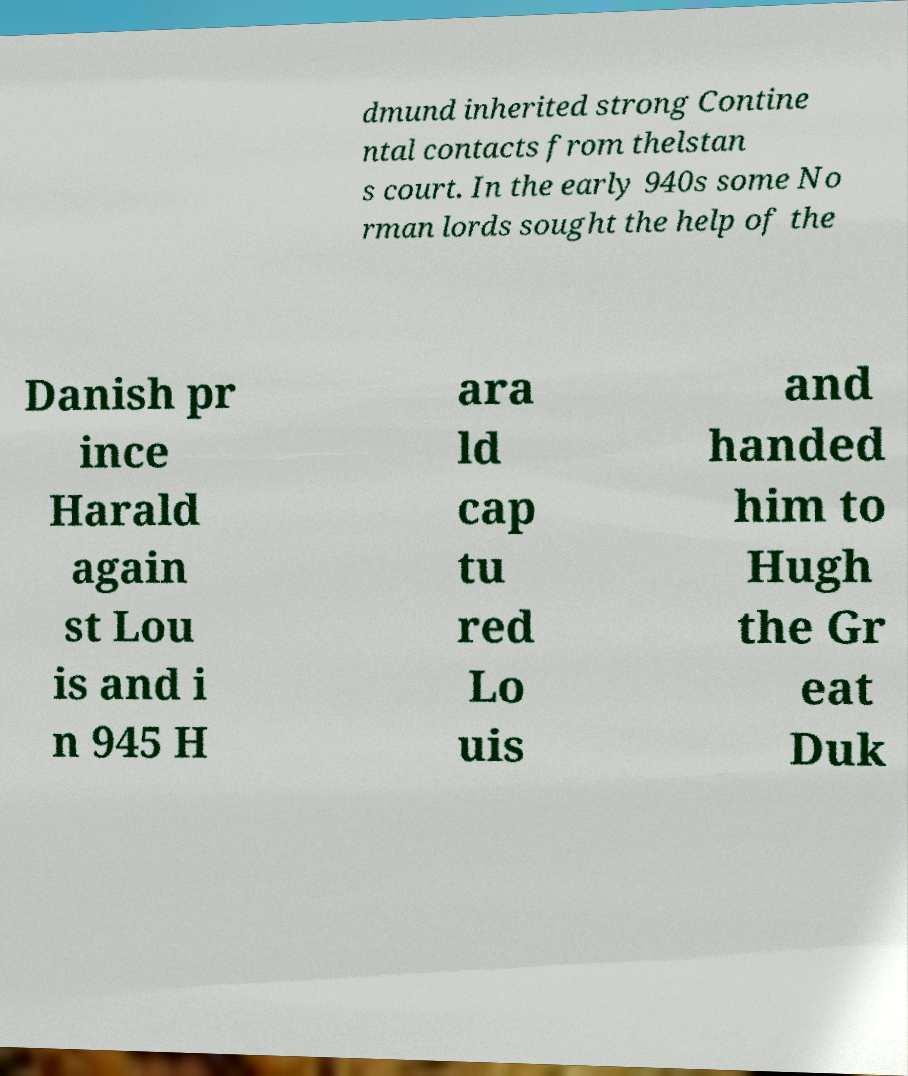Can you accurately transcribe the text from the provided image for me? dmund inherited strong Contine ntal contacts from thelstan s court. In the early 940s some No rman lords sought the help of the Danish pr ince Harald again st Lou is and i n 945 H ara ld cap tu red Lo uis and handed him to Hugh the Gr eat Duk 